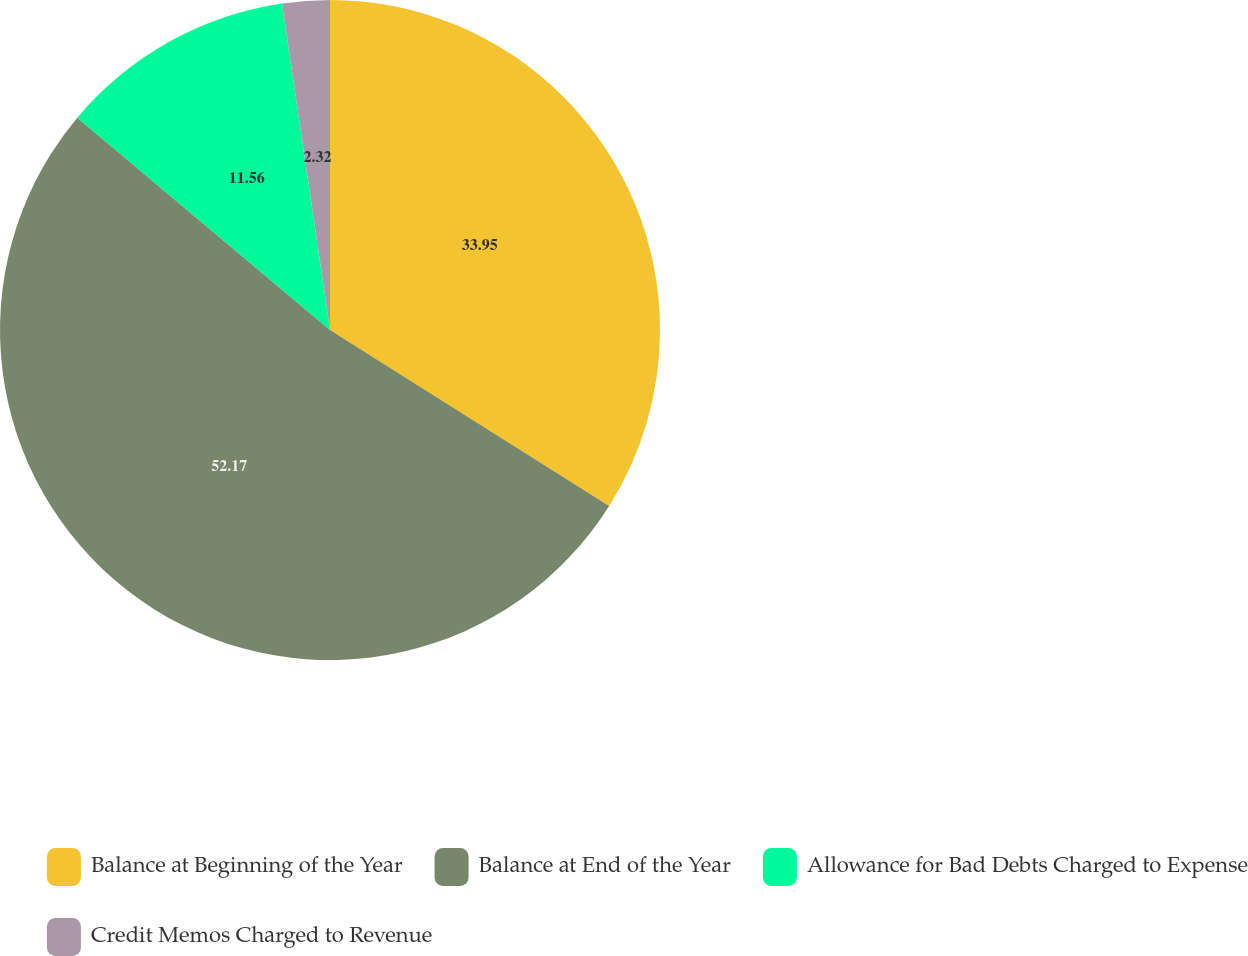Convert chart to OTSL. <chart><loc_0><loc_0><loc_500><loc_500><pie_chart><fcel>Balance at Beginning of the Year<fcel>Balance at End of the Year<fcel>Allowance for Bad Debts Charged to Expense<fcel>Credit Memos Charged to Revenue<nl><fcel>33.95%<fcel>52.17%<fcel>11.56%<fcel>2.32%<nl></chart> 